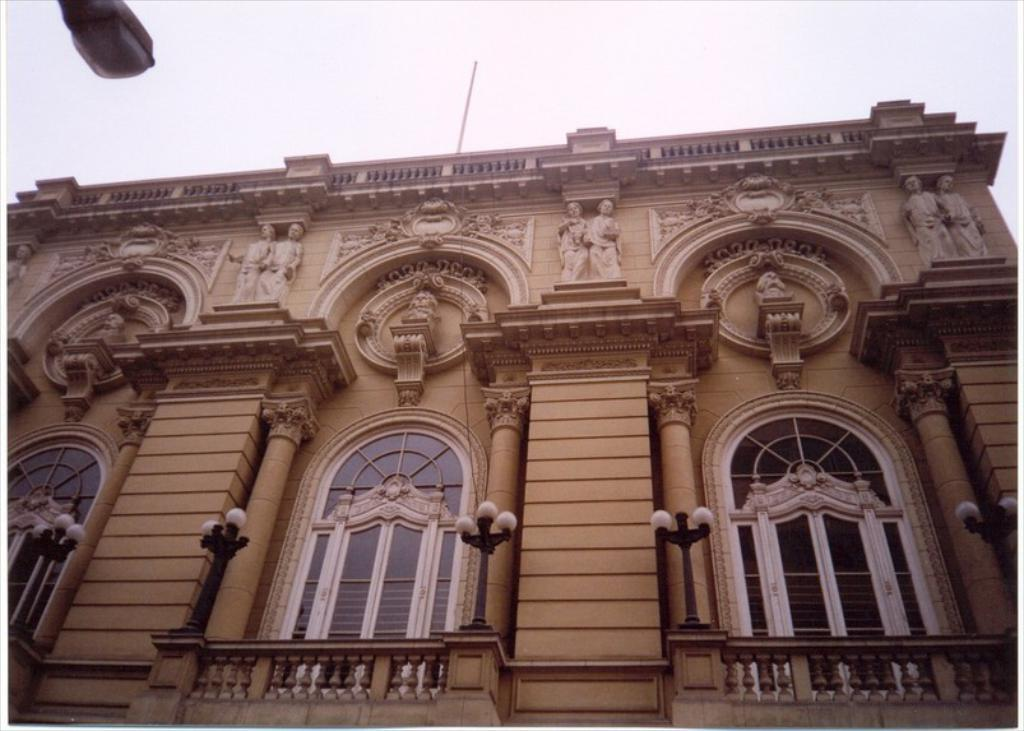What type of structure is present in the image? There is a building in the image. What features can be observed on the building? The building has windows, lights, and sculptures. Where is the light located in the image? There is a light on the left side of the image. What is visible at the top of the image? The sky is visible at the top of the image. What type of unit is being measured in the image? There is no indication of any unit being measured in the image. What detail can be observed on the sculptures in the image? The provided facts do not mention any specific details about the sculptures, so we cannot answer this question definitively. 